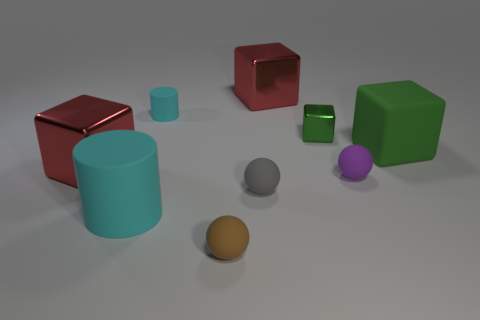Subtract all brown matte balls. How many balls are left? 2 Subtract 1 spheres. How many spheres are left? 2 Subtract all blue blocks. Subtract all gray cylinders. How many blocks are left? 4 Subtract all balls. How many objects are left? 6 Add 5 tiny balls. How many tiny balls are left? 8 Add 8 big cylinders. How many big cylinders exist? 9 Subtract 0 cyan balls. How many objects are left? 9 Subtract all large gray things. Subtract all red metallic cubes. How many objects are left? 7 